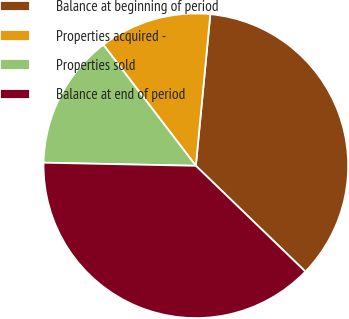Convert chart. <chart><loc_0><loc_0><loc_500><loc_500><pie_chart><fcel>Balance at beginning of period<fcel>Properties acquired -<fcel>Properties sold<fcel>Balance at end of period<nl><fcel>35.71%<fcel>11.9%<fcel>14.29%<fcel>38.1%<nl></chart> 